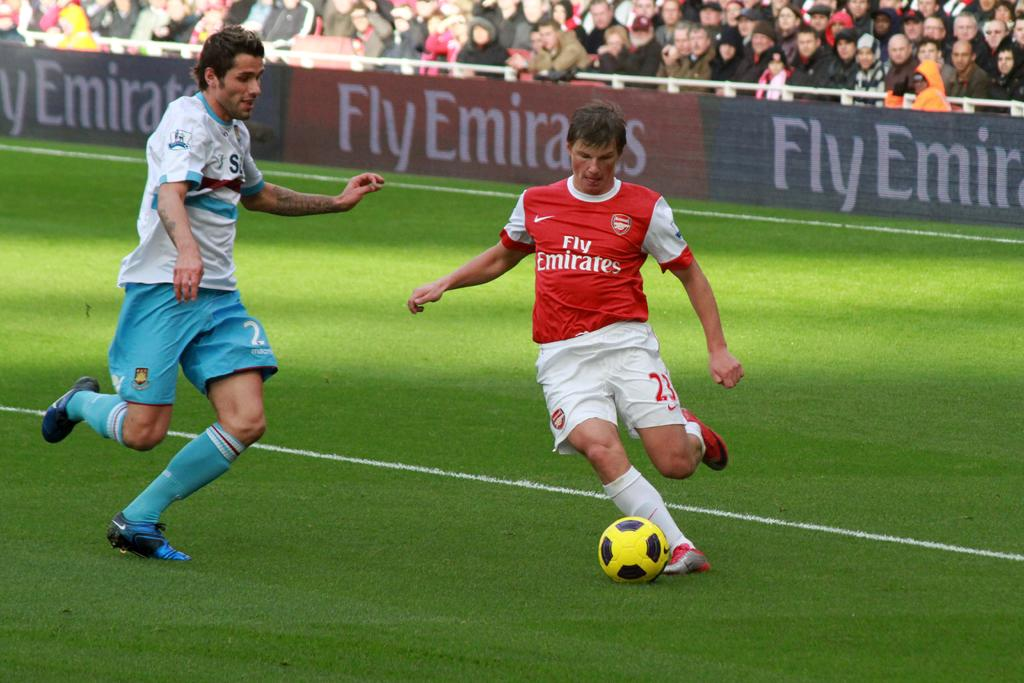How many people are in the image? There are two persons in the image. What are the persons wearing? The persons are wearing clothes. What activity are the persons engaged in? The persons are playing football. Can you describe the presence of other people in the image? There is a crowd visible in the image. What type of quill can be seen in the hands of the persons playing football? There is no quill present in the image; the persons are playing football with a ball. What brand of jeans are the persons wearing in the image? The provided facts do not mention the brand or type of jeans the persons are wearing; only that they are wearing clothes. 